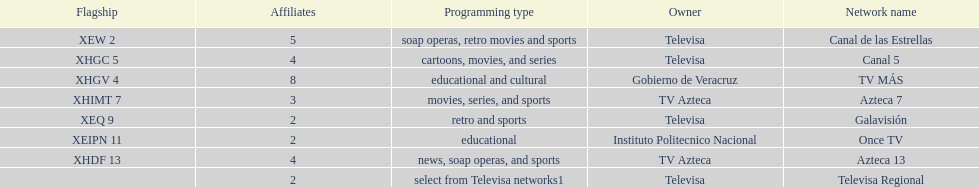Which is the only station with 8 affiliates? TV MÁS. 